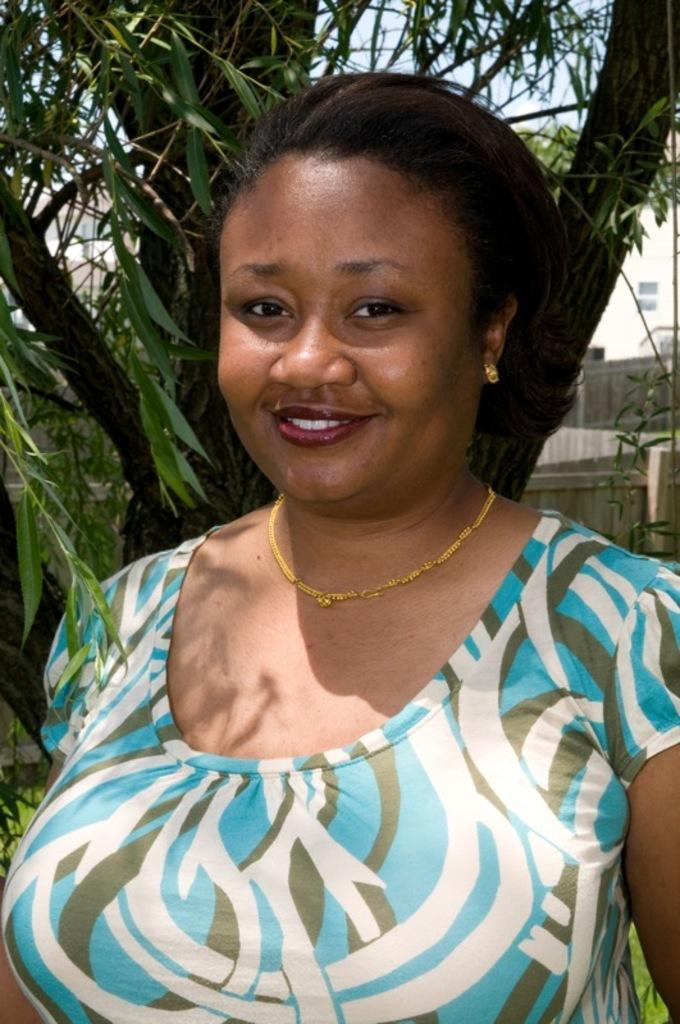In one or two sentences, can you explain what this image depicts? In this picture we see a woman wearing a blue t-shirt and a gold chain in front of a tree and smiling at someone. 